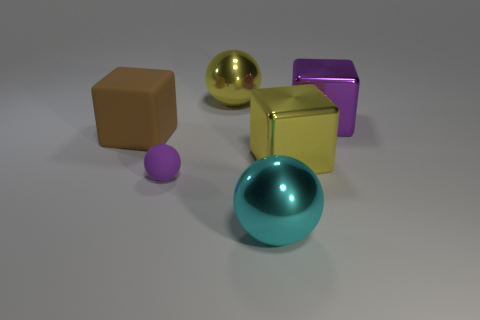How many tiny objects are either blue cubes or cyan metal spheres?
Ensure brevity in your answer.  0. Are there more large rubber blocks than tiny yellow shiny objects?
Provide a succinct answer. Yes. Does the big cyan thing have the same material as the big yellow cube?
Provide a succinct answer. Yes. Is the number of tiny purple matte balls in front of the brown thing greater than the number of gray matte spheres?
Provide a short and direct response. Yes. Is the color of the tiny matte ball the same as the big rubber cube?
Make the answer very short. No. How many large yellow things are the same shape as the big purple object?
Offer a terse response. 1. There is a sphere that is made of the same material as the big cyan object; what is its size?
Offer a terse response. Large. There is a metallic object that is both in front of the large brown thing and to the right of the cyan ball; what is its color?
Provide a short and direct response. Yellow. How many brown objects have the same size as the cyan object?
Ensure brevity in your answer.  1. What is the size of the object that is to the left of the yellow ball and in front of the brown object?
Make the answer very short. Small. 